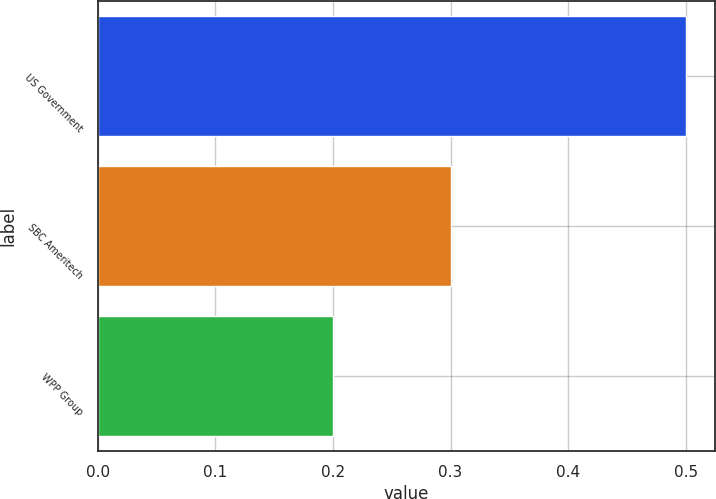Convert chart to OTSL. <chart><loc_0><loc_0><loc_500><loc_500><bar_chart><fcel>US Government<fcel>SBC Ameritech<fcel>WPP Group<nl><fcel>0.5<fcel>0.3<fcel>0.2<nl></chart> 